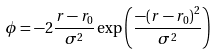Convert formula to latex. <formula><loc_0><loc_0><loc_500><loc_500>\phi = - 2 { \frac { r - { r _ { 0 } } } { \sigma ^ { 2 } } } \exp \left ( { \frac { - { { ( r - { r _ { 0 } } ) } ^ { 2 } } } { \sigma ^ { 2 } } } \right )</formula> 